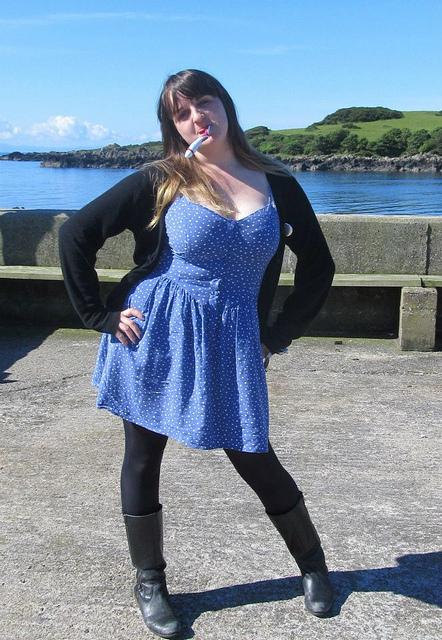To which direction of the woman is the sun located?

Choices:
A) back
B) left
C) right
D) front left 